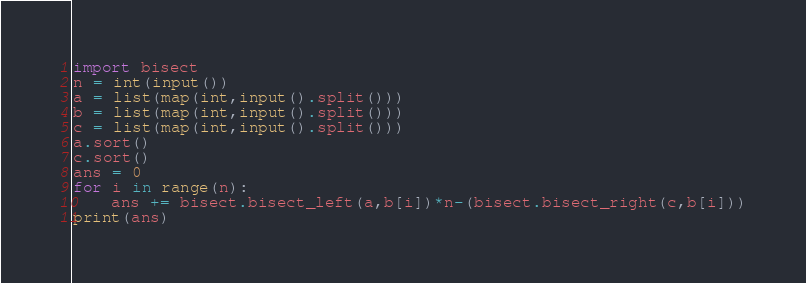Convert code to text. <code><loc_0><loc_0><loc_500><loc_500><_Python_>import bisect
n = int(input())
a = list(map(int,input().split()))
b = list(map(int,input().split()))
c = list(map(int,input().split()))
a.sort()
c.sort()
ans = 0
for i in range(n):
    ans += bisect.bisect_left(a,b[i])*n-(bisect.bisect_right(c,b[i]))
print(ans)</code> 